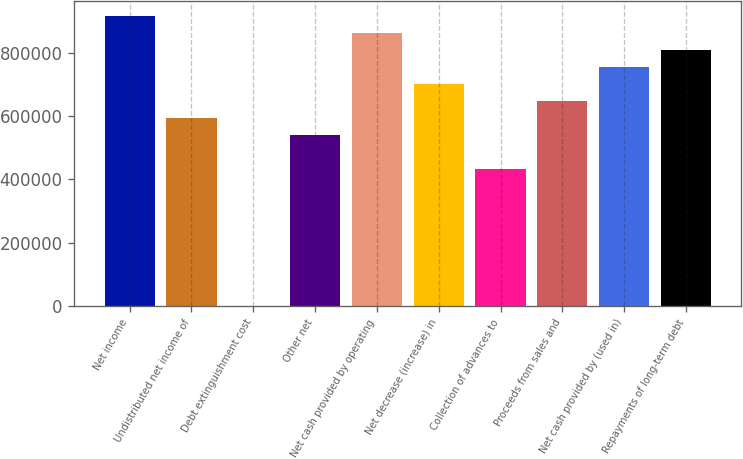Convert chart to OTSL. <chart><loc_0><loc_0><loc_500><loc_500><bar_chart><fcel>Net income<fcel>Undistributed net income of<fcel>Debt extinguishment cost<fcel>Other net<fcel>Net cash provided by operating<fcel>Net decrease (increase) in<fcel>Collection of advances to<fcel>Proceeds from sales and<fcel>Net cash provided by (used in)<fcel>Repayments of long-term debt<nl><fcel>917309<fcel>593600<fcel>135<fcel>539649<fcel>863357<fcel>701503<fcel>431746<fcel>647552<fcel>755455<fcel>809406<nl></chart> 